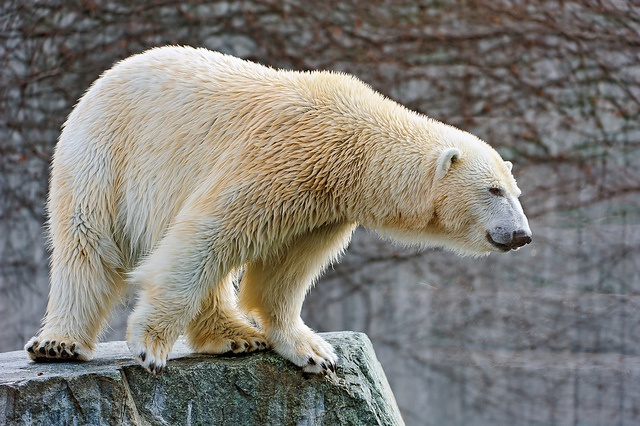Describe the objects in this image and their specific colors. I can see a bear in black, darkgray, lightgray, and tan tones in this image. 